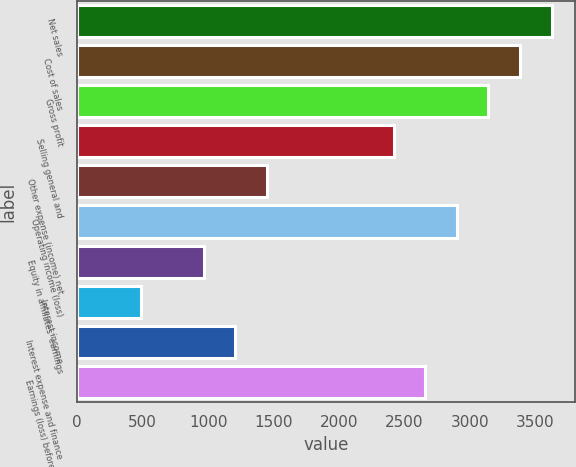Convert chart to OTSL. <chart><loc_0><loc_0><loc_500><loc_500><bar_chart><fcel>Net sales<fcel>Cost of sales<fcel>Gross profit<fcel>Selling general and<fcel>Other expense (income) net<fcel>Operating income (loss)<fcel>Equity in affiliates' earnings<fcel>Interest income<fcel>Interest expense and finance<fcel>Earnings (loss) before income<nl><fcel>3623.83<fcel>3382.3<fcel>3140.77<fcel>2416.18<fcel>1450.06<fcel>2899.24<fcel>967<fcel>483.94<fcel>1208.53<fcel>2657.71<nl></chart> 